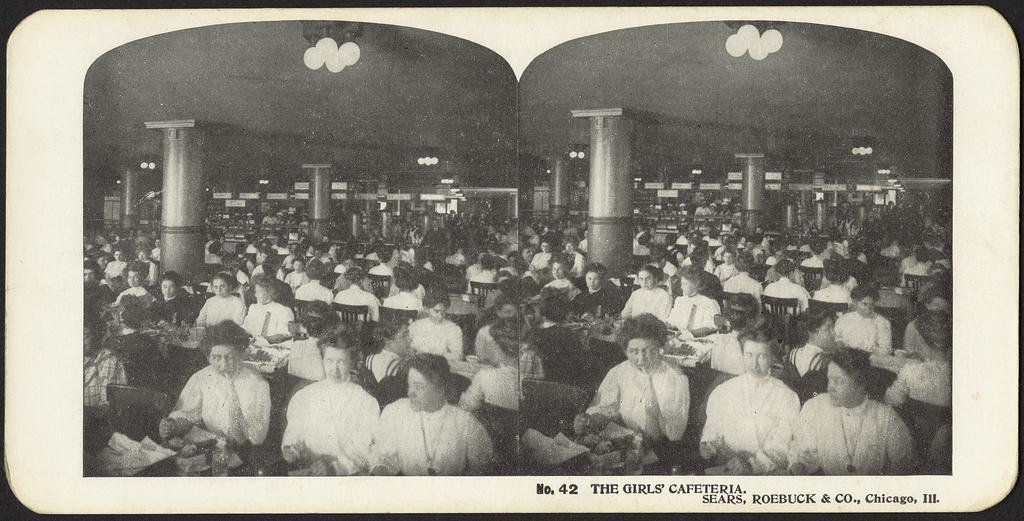How would you summarize this image in a sentence or two? In this image there are group of persons sitting. There is some text written on the image at the bottom right and there are lights hanging on the roof. There are pillars. 